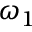<formula> <loc_0><loc_0><loc_500><loc_500>\omega _ { 1 }</formula> 